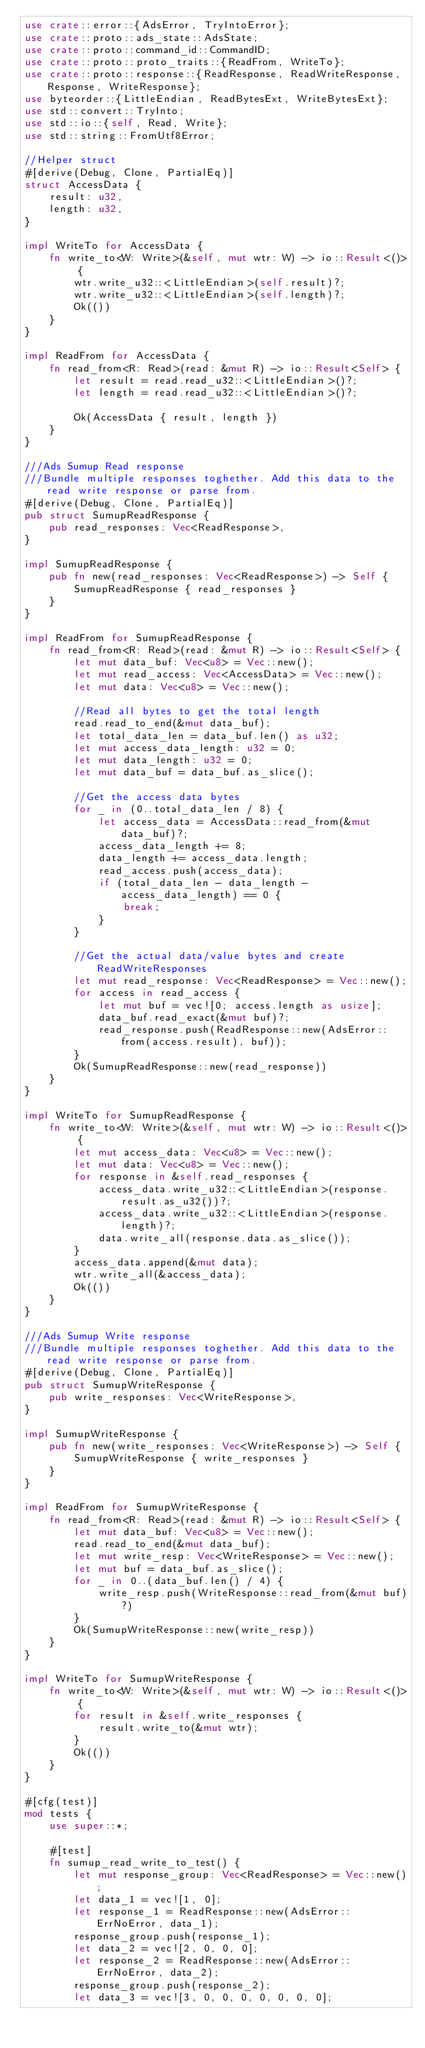Convert code to text. <code><loc_0><loc_0><loc_500><loc_500><_Rust_>use crate::error::{AdsError, TryIntoError};
use crate::proto::ads_state::AdsState;
use crate::proto::command_id::CommandID;
use crate::proto::proto_traits::{ReadFrom, WriteTo};
use crate::proto::response::{ReadResponse, ReadWriteResponse, Response, WriteResponse};
use byteorder::{LittleEndian, ReadBytesExt, WriteBytesExt};
use std::convert::TryInto;
use std::io::{self, Read, Write};
use std::string::FromUtf8Error;

//Helper struct
#[derive(Debug, Clone, PartialEq)]
struct AccessData {
    result: u32,
    length: u32,
}

impl WriteTo for AccessData {
    fn write_to<W: Write>(&self, mut wtr: W) -> io::Result<()> {
        wtr.write_u32::<LittleEndian>(self.result)?;
        wtr.write_u32::<LittleEndian>(self.length)?;
        Ok(())
    }
}

impl ReadFrom for AccessData {
    fn read_from<R: Read>(read: &mut R) -> io::Result<Self> {
        let result = read.read_u32::<LittleEndian>()?;
        let length = read.read_u32::<LittleEndian>()?;

        Ok(AccessData { result, length })
    }
}

///Ads Sumup Read response
///Bundle multiple responses toghether. Add this data to the read write response or parse from.
#[derive(Debug, Clone, PartialEq)]
pub struct SumupReadResponse {
    pub read_responses: Vec<ReadResponse>,
}

impl SumupReadResponse {
    pub fn new(read_responses: Vec<ReadResponse>) -> Self {
        SumupReadResponse { read_responses }
    }
}

impl ReadFrom for SumupReadResponse {
    fn read_from<R: Read>(read: &mut R) -> io::Result<Self> {
        let mut data_buf: Vec<u8> = Vec::new();
        let mut read_access: Vec<AccessData> = Vec::new();
        let mut data: Vec<u8> = Vec::new();

        //Read all bytes to get the total length
        read.read_to_end(&mut data_buf);
        let total_data_len = data_buf.len() as u32;
        let mut access_data_length: u32 = 0;
        let mut data_length: u32 = 0;
        let mut data_buf = data_buf.as_slice();

        //Get the access data bytes
        for _ in (0..total_data_len / 8) {
            let access_data = AccessData::read_from(&mut data_buf)?;
            access_data_length += 8;
            data_length += access_data.length;
            read_access.push(access_data);
            if (total_data_len - data_length - access_data_length) == 0 {
                break;
            }
        }

        //Get the actual data/value bytes and create ReadWriteResponses
        let mut read_response: Vec<ReadResponse> = Vec::new();
        for access in read_access {
            let mut buf = vec![0; access.length as usize];
            data_buf.read_exact(&mut buf)?;
            read_response.push(ReadResponse::new(AdsError::from(access.result), buf));
        }
        Ok(SumupReadResponse::new(read_response))
    }
}

impl WriteTo for SumupReadResponse {
    fn write_to<W: Write>(&self, mut wtr: W) -> io::Result<()> {
        let mut access_data: Vec<u8> = Vec::new();
        let mut data: Vec<u8> = Vec::new();
        for response in &self.read_responses {
            access_data.write_u32::<LittleEndian>(response.result.as_u32())?;
            access_data.write_u32::<LittleEndian>(response.length)?;
            data.write_all(response.data.as_slice());
        }
        access_data.append(&mut data);
        wtr.write_all(&access_data);
        Ok(())
    }
}

///Ads Sumup Write response
///Bundle multiple responses toghether. Add this data to the read write response or parse from.
#[derive(Debug, Clone, PartialEq)]
pub struct SumupWriteResponse {
    pub write_responses: Vec<WriteResponse>,
}

impl SumupWriteResponse {
    pub fn new(write_responses: Vec<WriteResponse>) -> Self {
        SumupWriteResponse { write_responses }
    }
}

impl ReadFrom for SumupWriteResponse {
    fn read_from<R: Read>(read: &mut R) -> io::Result<Self> {
        let mut data_buf: Vec<u8> = Vec::new();
        read.read_to_end(&mut data_buf);
        let mut write_resp: Vec<WriteResponse> = Vec::new();
        let mut buf = data_buf.as_slice();
        for _ in 0..(data_buf.len() / 4) {
            write_resp.push(WriteResponse::read_from(&mut buf)?)
        }
        Ok(SumupWriteResponse::new(write_resp))
    }
}

impl WriteTo for SumupWriteResponse {
    fn write_to<W: Write>(&self, mut wtr: W) -> io::Result<()> {
        for result in &self.write_responses {
            result.write_to(&mut wtr);
        }
        Ok(())
    }
}

#[cfg(test)]
mod tests {
    use super::*;

    #[test]
    fn sumup_read_write_to_test() {
        let mut response_group: Vec<ReadResponse> = Vec::new();
        let data_1 = vec![1, 0];
        let response_1 = ReadResponse::new(AdsError::ErrNoError, data_1);
        response_group.push(response_1);
        let data_2 = vec![2, 0, 0, 0];
        let response_2 = ReadResponse::new(AdsError::ErrNoError, data_2);
        response_group.push(response_2);
        let data_3 = vec![3, 0, 0, 0, 0, 0, 0, 0];</code> 